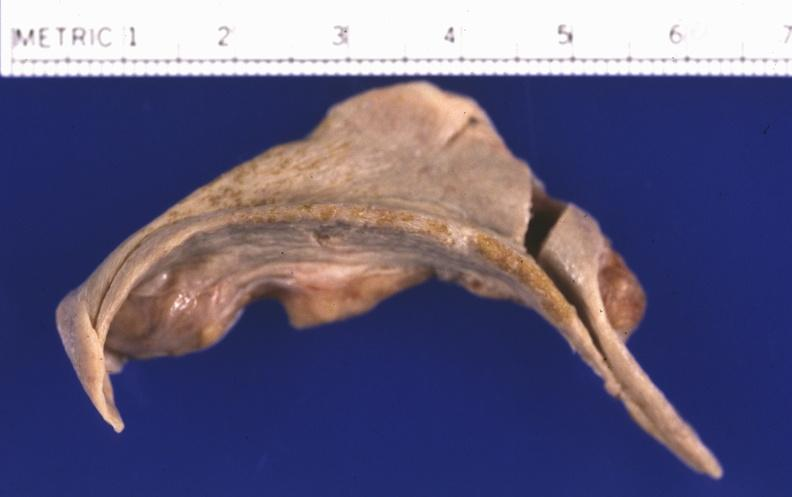what does this image show?
Answer the question using a single word or phrase. Spleen 